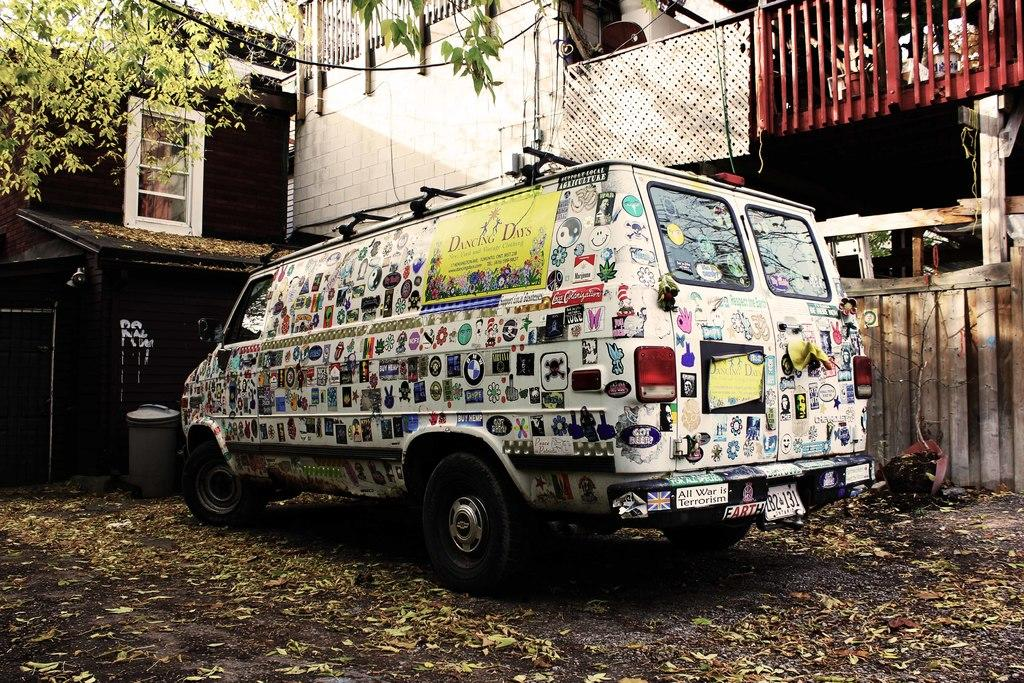What type of structure can be seen in the image? There is a wall in the image. What feature is present on the wall? There are railings in the image. What natural elements are visible in the image? Leaves and branches are present in the image. What man-made object can be seen in the image? There is a vehicle in the image. What else can be found in the image besides the mentioned elements? There are objects in the image. Where are the leaves located in the image? Leaves are on the ground at the bottom portion of the image. What type of cannon is being fueled in the image? There is no cannon present in the image, and therefore no fueling can be observed. What is the end result of the objects in the image? The image does not depict a specific end result for the objects; it simply shows their presence. 